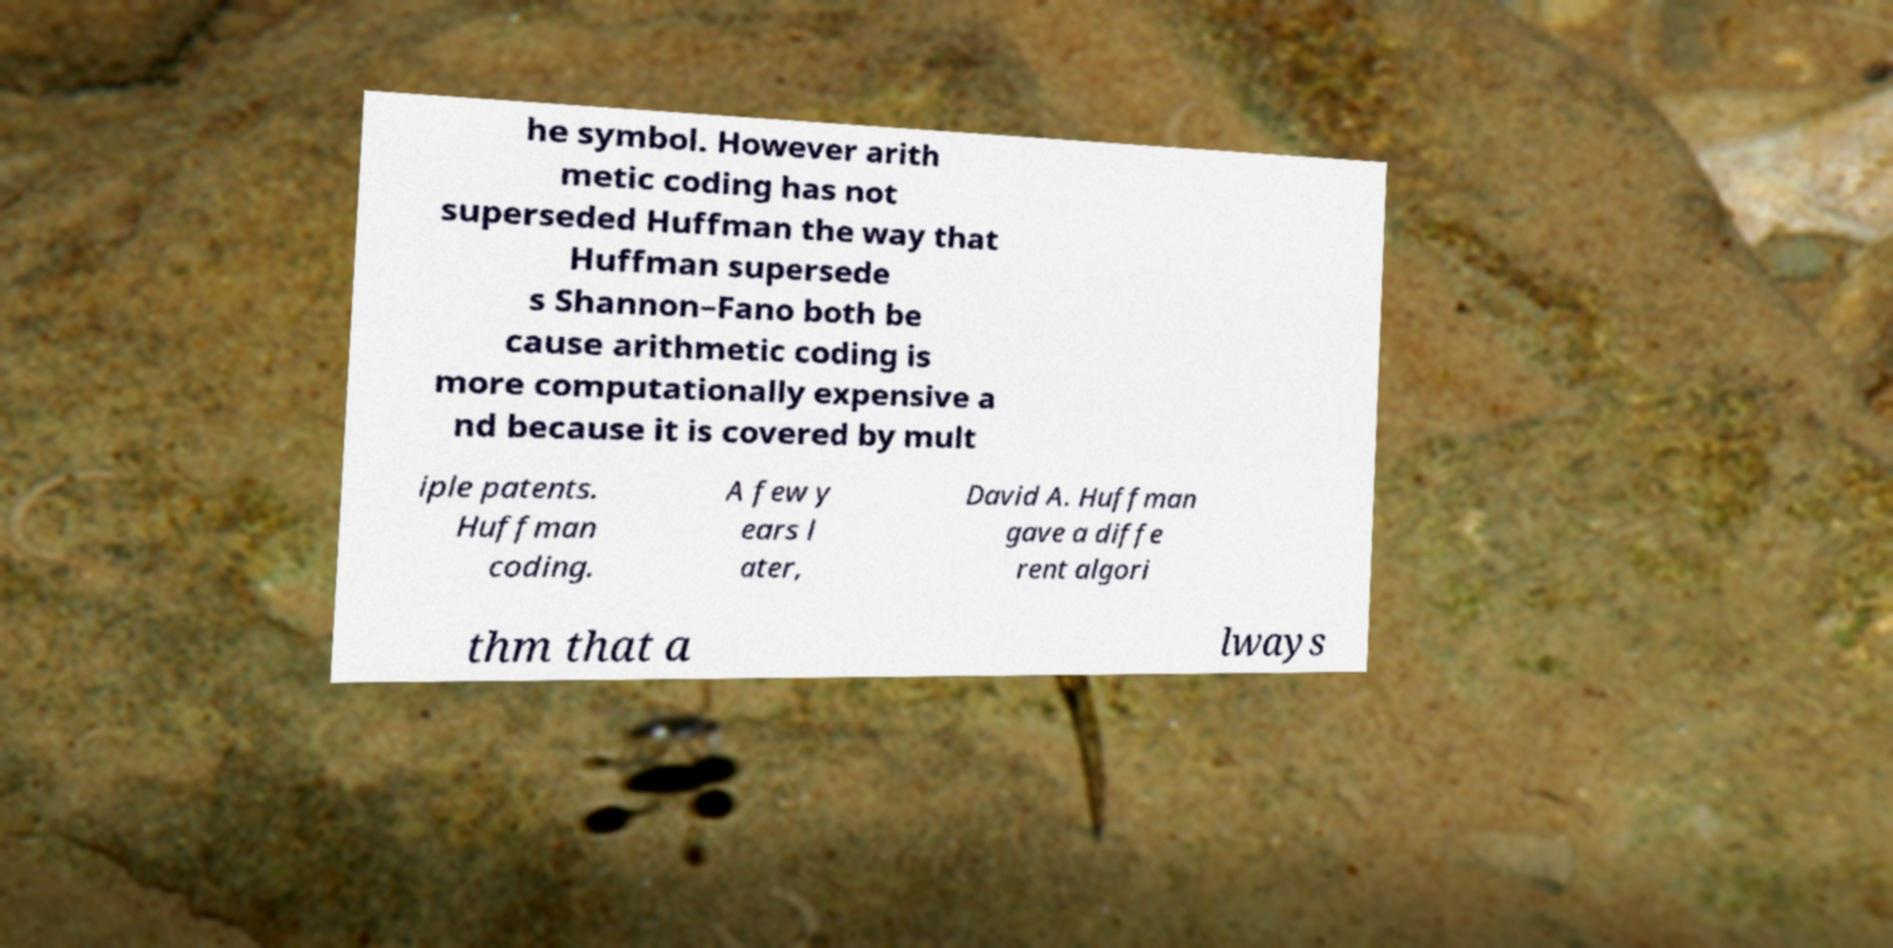I need the written content from this picture converted into text. Can you do that? he symbol. However arith metic coding has not superseded Huffman the way that Huffman supersede s Shannon–Fano both be cause arithmetic coding is more computationally expensive a nd because it is covered by mult iple patents. Huffman coding. A few y ears l ater, David A. Huffman gave a diffe rent algori thm that a lways 